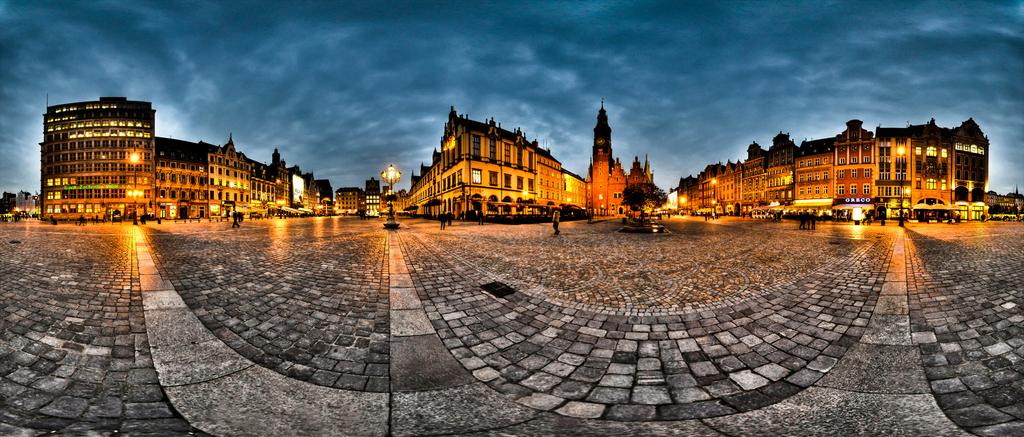What type of structures are present in the image? There are buildings with windows in the image. What can be seen inside the buildings? Lights are visible in the image. What natural elements are present in the image? There are trees in the image. What is visible in the background of the image? The sky with clouds is visible in the background of the image. How many people are present in the image? There are many people in the image. What type of paper is being used by the dogs in the image? There are no dogs present in the image, so there is no paper being used by them. 